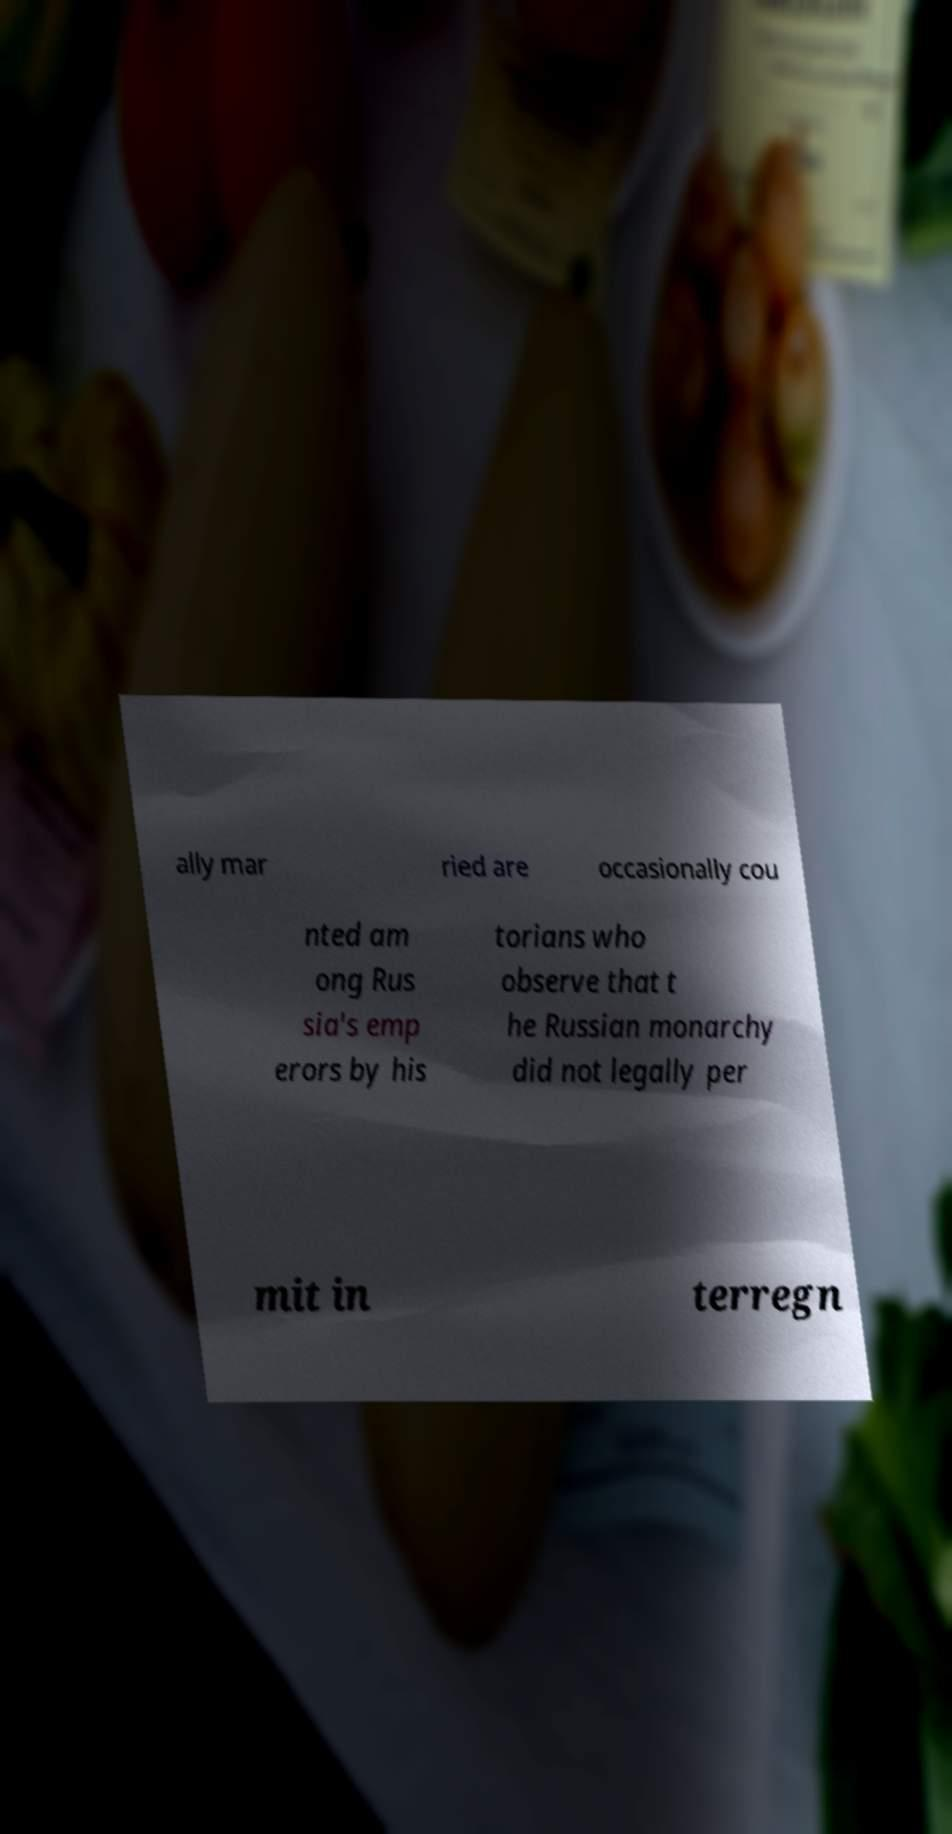Could you extract and type out the text from this image? ally mar ried are occasionally cou nted am ong Rus sia's emp erors by his torians who observe that t he Russian monarchy did not legally per mit in terregn 